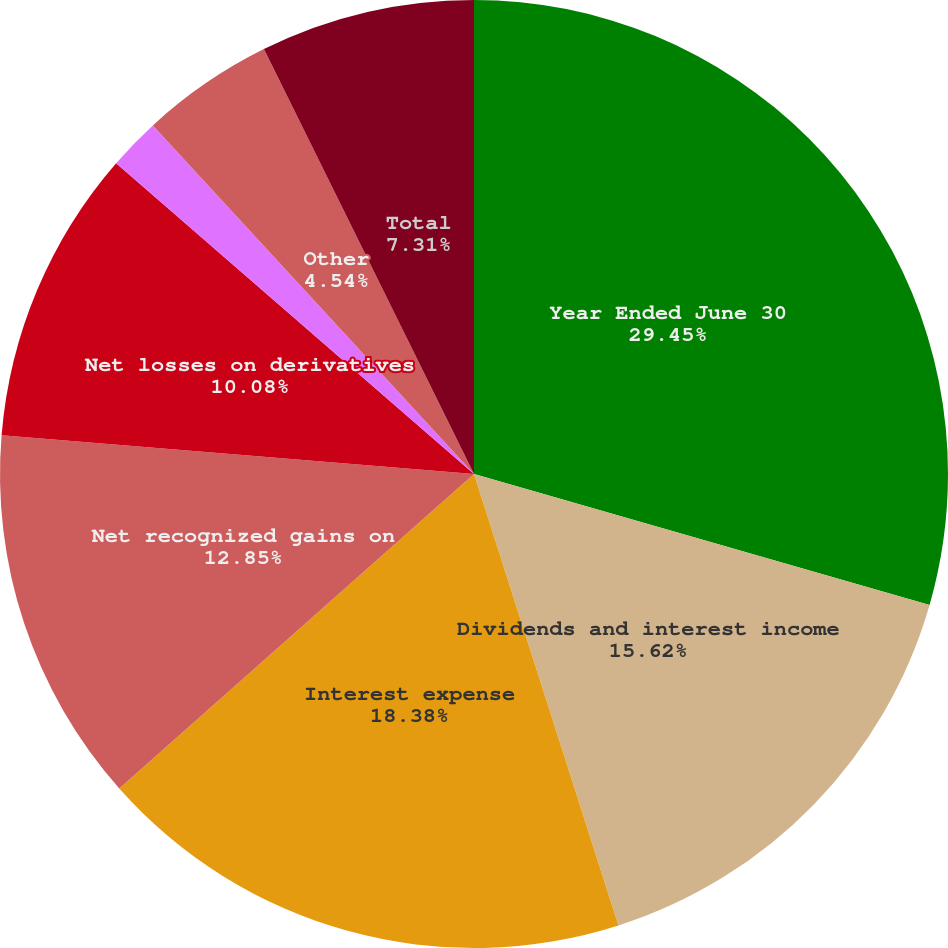<chart> <loc_0><loc_0><loc_500><loc_500><pie_chart><fcel>Year Ended June 30<fcel>Dividends and interest income<fcel>Interest expense<fcel>Net recognized gains on<fcel>Net losses on derivatives<fcel>Net gains (losses) on foreign<fcel>Other<fcel>Total<nl><fcel>29.46%<fcel>15.62%<fcel>18.39%<fcel>12.85%<fcel>10.08%<fcel>1.77%<fcel>4.54%<fcel>7.31%<nl></chart> 